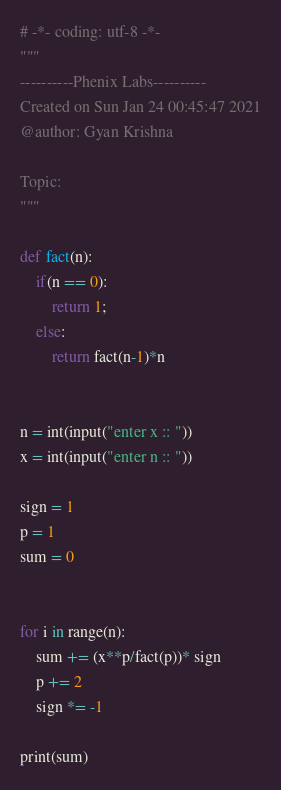Convert code to text. <code><loc_0><loc_0><loc_500><loc_500><_Python_># -*- coding: utf-8 -*-
"""
----------Phenix Labs----------
Created on Sun Jan 24 00:45:47 2021
@author: Gyan Krishna

Topic:
"""

def fact(n):
    if(n == 0):
        return 1;
    else:
        return fact(n-1)*n


n = int(input("enter x :: "))
x = int(input("enter n :: "))

sign = 1
p = 1
sum = 0


for i in range(n):
    sum += (x**p/fact(p))* sign
    p += 2
    sign *= -1

print(sum)

</code> 